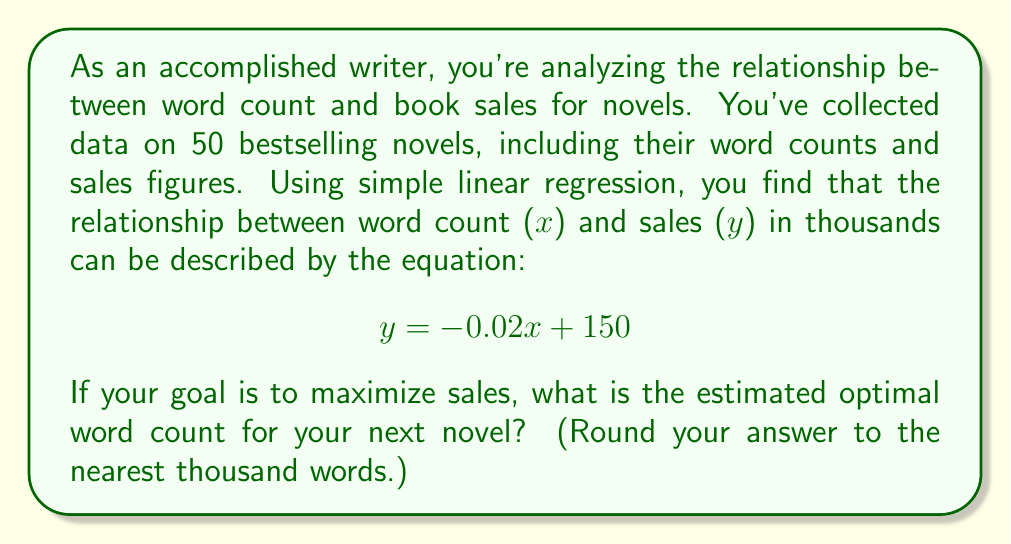Help me with this question. To solve this problem, we need to understand the implications of the given linear regression equation and how it relates to book sales.

1. Interpret the equation:
   $$ y = -0.02x + 150 $$
   Where:
   - y is the predicted sales in thousands
   - x is the word count
   - -0.02 is the slope (indicating a negative relationship)
   - 150 is the y-intercept

2. Analyze the relationship:
   The negative slope (-0.02) suggests that as word count increases, sales tend to decrease. This implies that shorter novels generally sell better in this dataset.

3. Find the optimal word count:
   Since the relationship is linear and negative, the optimal word count to maximize sales would be the lowest possible word count. However, we need to consider practical constraints.

4. Consider practical limits:
   Novels typically have a minimum word count to be considered full-length. The general industry standard for a novel is around 50,000 words.

5. Calculate the predicted sales for the minimum word count:
   $$ y = -0.02(50,000) + 150 $$
   $$ y = -1000 + 150 = -850 $$

6. Interpret the result:
   The negative sales figure is not meaningful in reality. This suggests that the model's predictions may not be reliable for extremely low word counts.

7. Conclusion:
   Given the limitations of the model and practical considerations, the optimal word count would be the lowest acceptable word count for a novel, which is typically around 50,000 words.
Answer: 50,000 words 